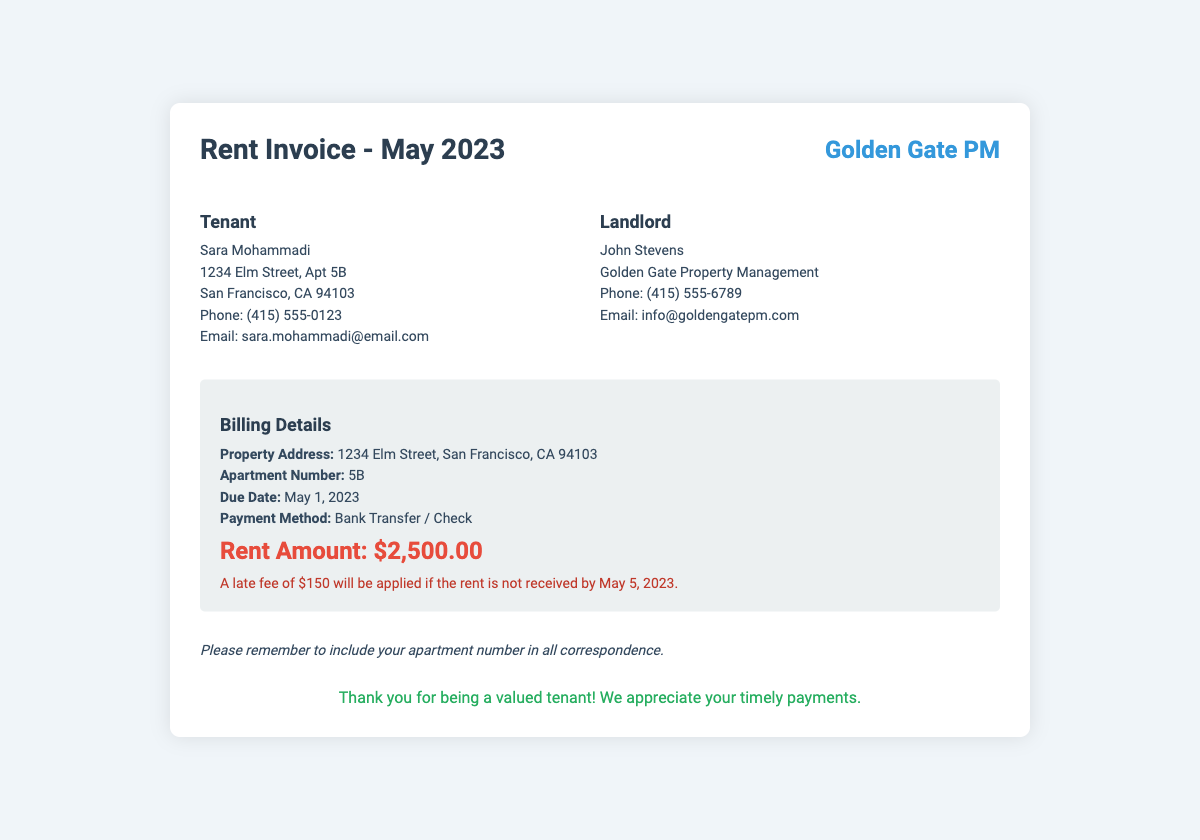What is the rent amount? The rent amount is specified in the billing details section of the document.
Answer: $2,500.00 When is the rent due? The document clearly states the due date for the rent payment.
Answer: May 1, 2023 What is the late fee amount? The late fee policy is mentioned under the billing details section.
Answer: $150 Who is the landlord? The landlord's name is listed in the contact section of the document.
Answer: John Stevens What payment methods are accepted? The payment methods are detailed in the billing details section of the document.
Answer: Bank Transfer / Check What happens if the rent is received after the due date? The document states the consequences if rent is paid late.
Answer: A late fee will be applied What is the property address? The address is provided in the billing details for the property.
Answer: 1234 Elm Street, San Francisco, CA 94103 Who is the tenant? The tenant’s name is given at the top of the document.
Answer: Sara Mohammadi 